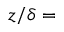Convert formula to latex. <formula><loc_0><loc_0><loc_500><loc_500>z / \delta =</formula> 